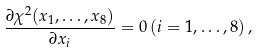Convert formula to latex. <formula><loc_0><loc_0><loc_500><loc_500>\frac { \partial \chi ^ { 2 } ( x _ { 1 } , \dots , x _ { 8 } ) } { \partial x _ { i } } = 0 \, ( i = 1 , \dots , 8 ) \, ,</formula> 